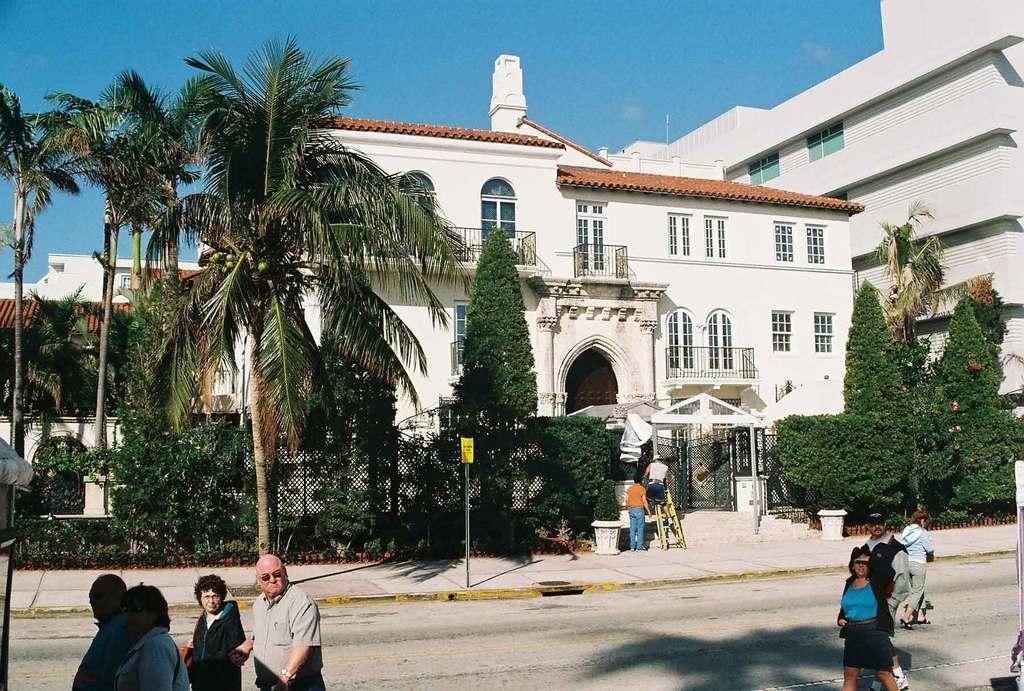Please provide a concise description of this image. In this picture we can see a few people on the left side. Some people are walking on the path on the right side. We can see a board on the pole. There is some fencing around plants. We can see few trees and buildings in the background. Sky is blue in color. 